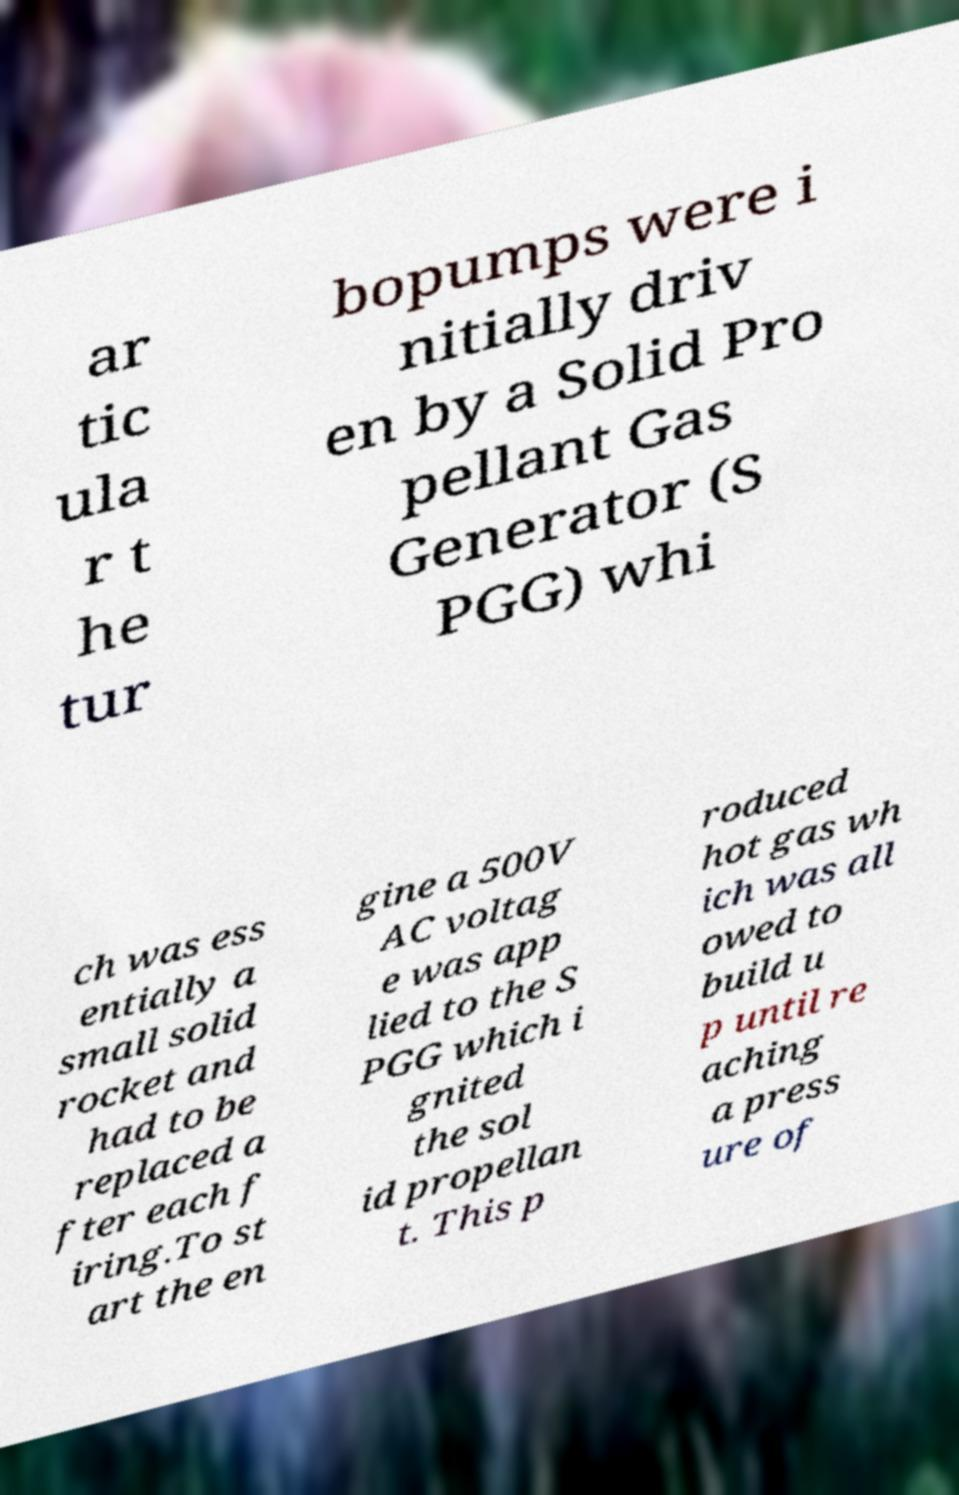Can you read and provide the text displayed in the image?This photo seems to have some interesting text. Can you extract and type it out for me? ar tic ula r t he tur bopumps were i nitially driv en by a Solid Pro pellant Gas Generator (S PGG) whi ch was ess entially a small solid rocket and had to be replaced a fter each f iring.To st art the en gine a 500V AC voltag e was app lied to the S PGG which i gnited the sol id propellan t. This p roduced hot gas wh ich was all owed to build u p until re aching a press ure of 